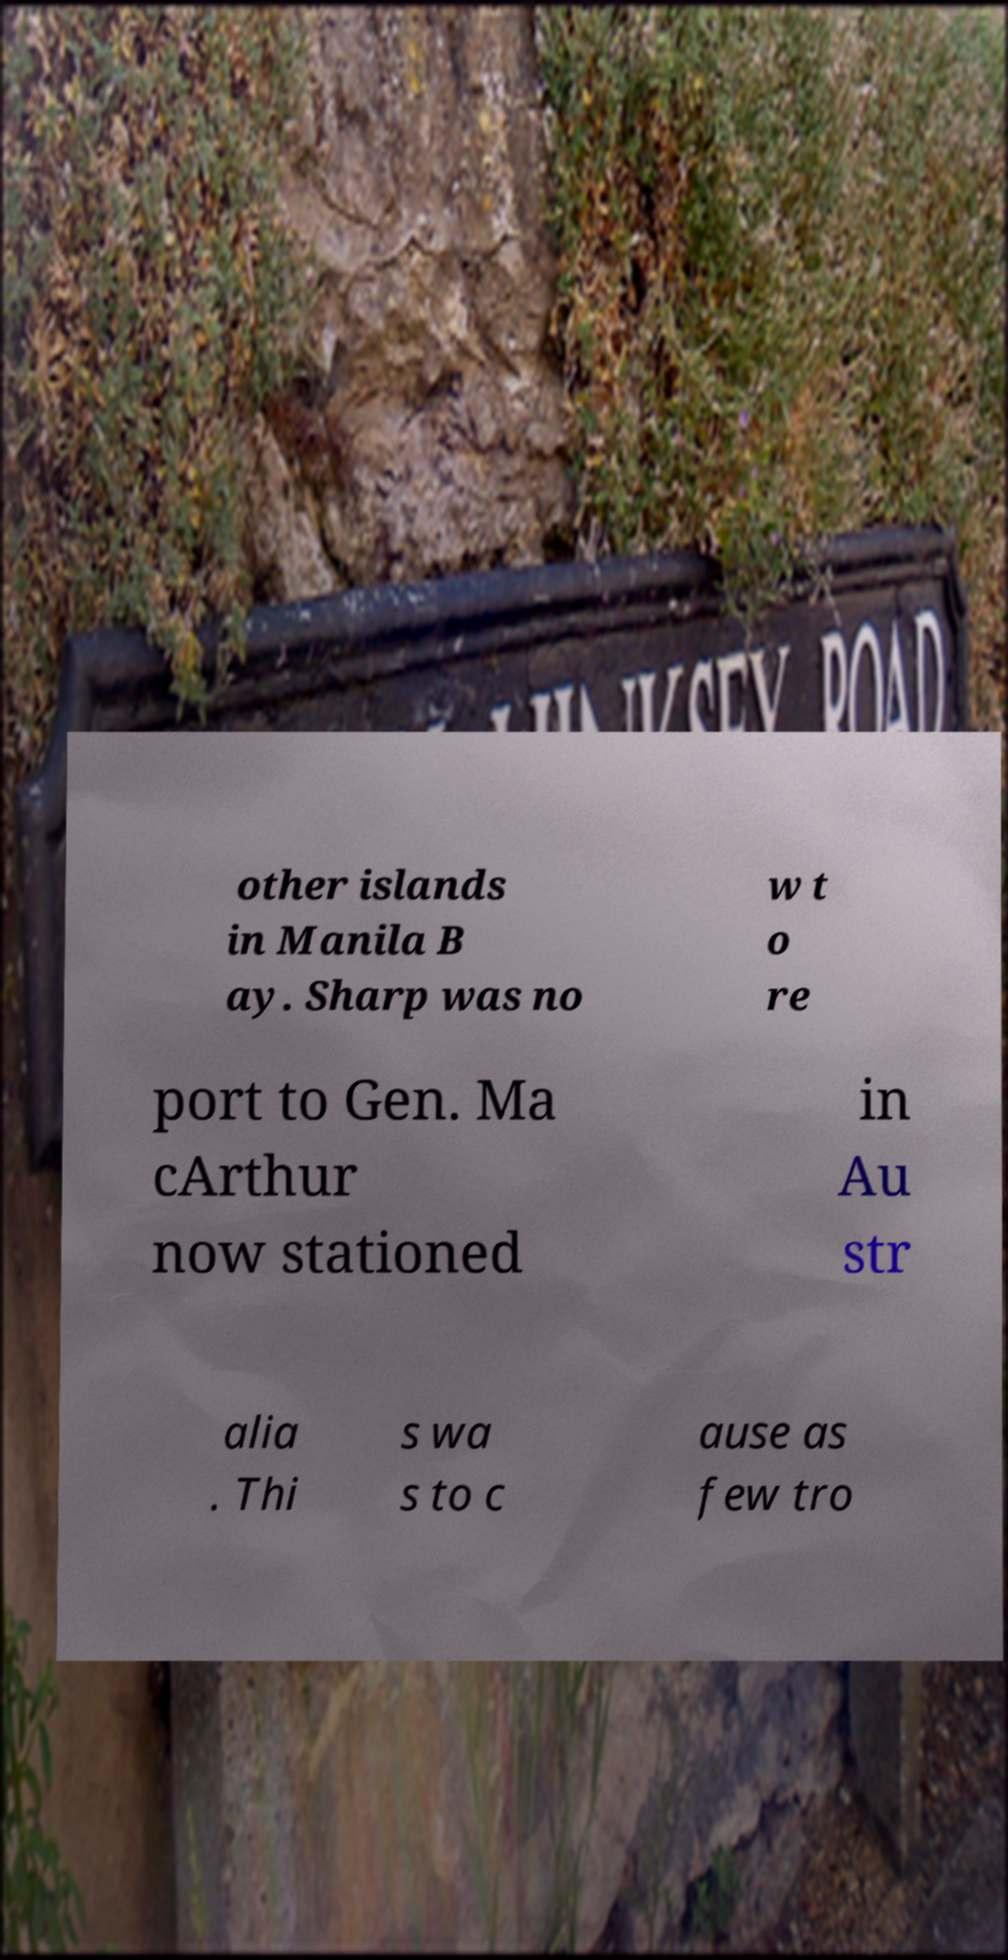Can you read and provide the text displayed in the image?This photo seems to have some interesting text. Can you extract and type it out for me? other islands in Manila B ay. Sharp was no w t o re port to Gen. Ma cArthur now stationed in Au str alia . Thi s wa s to c ause as few tro 